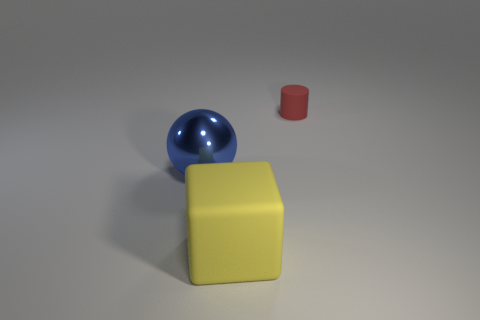Subtract all gray cubes. Subtract all brown spheres. How many cubes are left? 1 Add 1 purple metal blocks. How many objects exist? 4 Subtract all blocks. How many objects are left? 2 Subtract all gray shiny things. Subtract all large blocks. How many objects are left? 2 Add 2 big yellow objects. How many big yellow objects are left? 3 Add 1 blue spheres. How many blue spheres exist? 2 Subtract 0 cyan cubes. How many objects are left? 3 